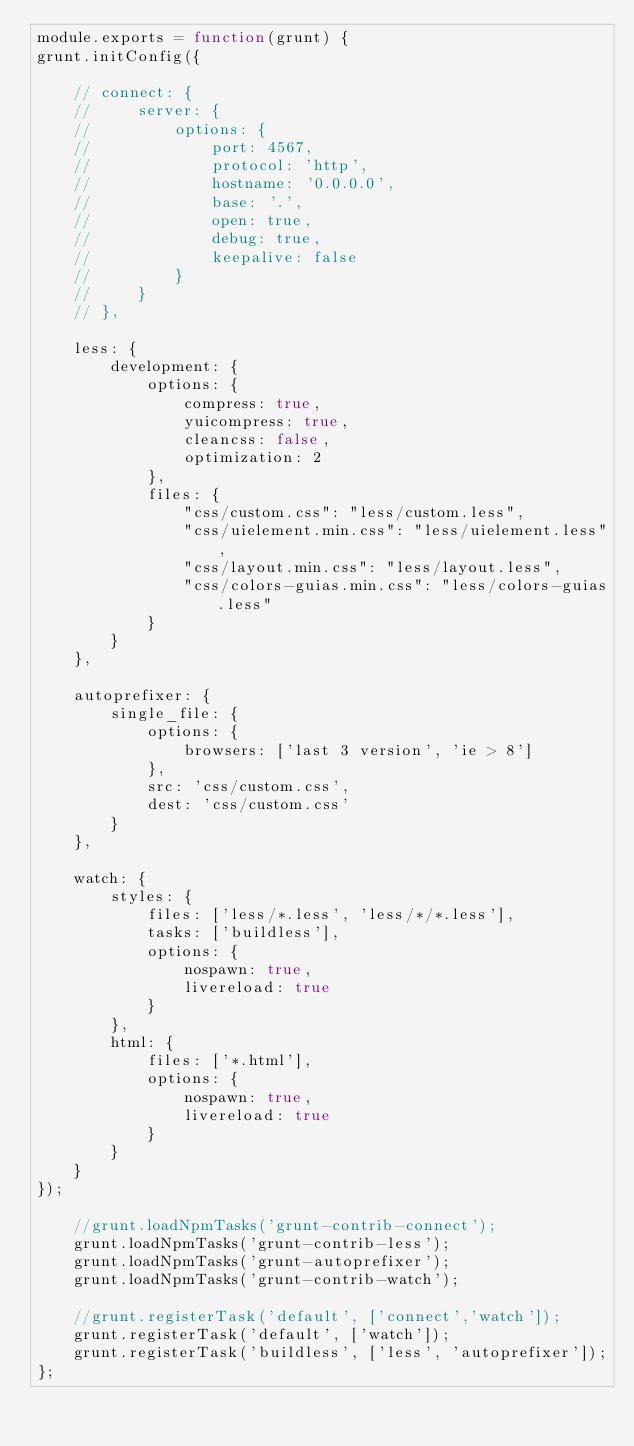Convert code to text. <code><loc_0><loc_0><loc_500><loc_500><_JavaScript_>module.exports = function(grunt) {
grunt.initConfig({

    // connect: {
    //     server: {
    //         options: {
    //             port: 4567,
    //             protocol: 'http',
    //             hostname: '0.0.0.0',
    //             base: '.',
    //             open: true,
    //             debug: true,
    //             keepalive: false
    //         }
    //     }
    // },

    less: {
        development: {
            options: {
                compress: true,
                yuicompress: true,
                cleancss: false,
                optimization: 2
            },
            files: {
                "css/custom.css": "less/custom.less",
                "css/uielement.min.css": "less/uielement.less",
                "css/layout.min.css": "less/layout.less",
                "css/colors-guias.min.css": "less/colors-guias.less"
            }
        }
    },

    autoprefixer: {
        single_file: {
            options: {
                browsers: ['last 3 version', 'ie > 8']
            },
            src: 'css/custom.css',
            dest: 'css/custom.css'
        }
    },

    watch: {
        styles: {
            files: ['less/*.less', 'less/*/*.less'],
            tasks: ['buildless'],
            options: {
                nospawn: true,
                livereload: true
            }
        },
        html: {
            files: ['*.html'],
            options: {
                nospawn: true,
                livereload: true
            }
        }
    }
});

    //grunt.loadNpmTasks('grunt-contrib-connect');
    grunt.loadNpmTasks('grunt-contrib-less');
    grunt.loadNpmTasks('grunt-autoprefixer');
    grunt.loadNpmTasks('grunt-contrib-watch');

    //grunt.registerTask('default', ['connect','watch']);
    grunt.registerTask('default', ['watch']);
    grunt.registerTask('buildless', ['less', 'autoprefixer']);
};
</code> 